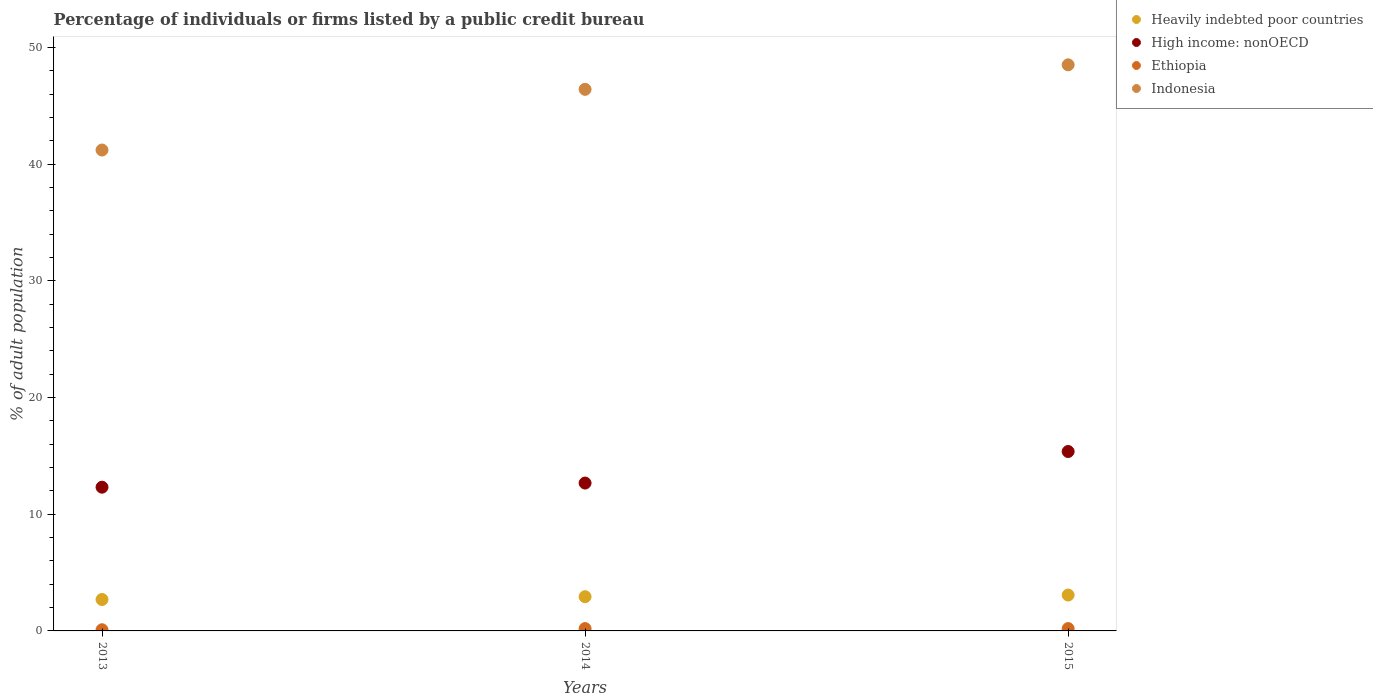What is the percentage of population listed by a public credit bureau in Heavily indebted poor countries in 2015?
Offer a terse response. 3.07. Across all years, what is the maximum percentage of population listed by a public credit bureau in Heavily indebted poor countries?
Give a very brief answer. 3.07. Across all years, what is the minimum percentage of population listed by a public credit bureau in Heavily indebted poor countries?
Offer a very short reply. 2.69. In which year was the percentage of population listed by a public credit bureau in Indonesia minimum?
Your answer should be very brief. 2013. What is the total percentage of population listed by a public credit bureau in Indonesia in the graph?
Keep it short and to the point. 136.1. What is the difference between the percentage of population listed by a public credit bureau in Ethiopia in 2014 and that in 2015?
Make the answer very short. 0. What is the difference between the percentage of population listed by a public credit bureau in High income: nonOECD in 2015 and the percentage of population listed by a public credit bureau in Heavily indebted poor countries in 2013?
Your answer should be very brief. 12.68. What is the average percentage of population listed by a public credit bureau in Heavily indebted poor countries per year?
Your answer should be very brief. 2.9. In the year 2013, what is the difference between the percentage of population listed by a public credit bureau in Heavily indebted poor countries and percentage of population listed by a public credit bureau in Ethiopia?
Provide a succinct answer. 2.59. In how many years, is the percentage of population listed by a public credit bureau in Indonesia greater than 20 %?
Provide a short and direct response. 3. What is the ratio of the percentage of population listed by a public credit bureau in High income: nonOECD in 2013 to that in 2015?
Your response must be concise. 0.8. Is the percentage of population listed by a public credit bureau in Heavily indebted poor countries in 2013 less than that in 2015?
Give a very brief answer. Yes. Is the difference between the percentage of population listed by a public credit bureau in Heavily indebted poor countries in 2013 and 2015 greater than the difference between the percentage of population listed by a public credit bureau in Ethiopia in 2013 and 2015?
Make the answer very short. No. What is the difference between the highest and the second highest percentage of population listed by a public credit bureau in Heavily indebted poor countries?
Your response must be concise. 0.14. What is the difference between the highest and the lowest percentage of population listed by a public credit bureau in Indonesia?
Offer a very short reply. 7.3. In how many years, is the percentage of population listed by a public credit bureau in High income: nonOECD greater than the average percentage of population listed by a public credit bureau in High income: nonOECD taken over all years?
Provide a short and direct response. 1. Is it the case that in every year, the sum of the percentage of population listed by a public credit bureau in High income: nonOECD and percentage of population listed by a public credit bureau in Heavily indebted poor countries  is greater than the percentage of population listed by a public credit bureau in Ethiopia?
Your response must be concise. Yes. Does the percentage of population listed by a public credit bureau in High income: nonOECD monotonically increase over the years?
Make the answer very short. Yes. Is the percentage of population listed by a public credit bureau in High income: nonOECD strictly less than the percentage of population listed by a public credit bureau in Ethiopia over the years?
Provide a short and direct response. No. How many years are there in the graph?
Your answer should be compact. 3. What is the difference between two consecutive major ticks on the Y-axis?
Offer a terse response. 10. Does the graph contain grids?
Give a very brief answer. No. How many legend labels are there?
Your response must be concise. 4. How are the legend labels stacked?
Give a very brief answer. Vertical. What is the title of the graph?
Give a very brief answer. Percentage of individuals or firms listed by a public credit bureau. What is the label or title of the Y-axis?
Make the answer very short. % of adult population. What is the % of adult population in Heavily indebted poor countries in 2013?
Your answer should be compact. 2.69. What is the % of adult population of High income: nonOECD in 2013?
Make the answer very short. 12.31. What is the % of adult population of Indonesia in 2013?
Your response must be concise. 41.2. What is the % of adult population in Heavily indebted poor countries in 2014?
Your response must be concise. 2.93. What is the % of adult population in High income: nonOECD in 2014?
Provide a short and direct response. 12.67. What is the % of adult population of Ethiopia in 2014?
Your answer should be compact. 0.2. What is the % of adult population of Indonesia in 2014?
Ensure brevity in your answer.  46.4. What is the % of adult population in Heavily indebted poor countries in 2015?
Your answer should be very brief. 3.07. What is the % of adult population of High income: nonOECD in 2015?
Offer a very short reply. 15.37. What is the % of adult population in Ethiopia in 2015?
Give a very brief answer. 0.2. What is the % of adult population of Indonesia in 2015?
Make the answer very short. 48.5. Across all years, what is the maximum % of adult population in Heavily indebted poor countries?
Your answer should be compact. 3.07. Across all years, what is the maximum % of adult population in High income: nonOECD?
Ensure brevity in your answer.  15.37. Across all years, what is the maximum % of adult population in Ethiopia?
Ensure brevity in your answer.  0.2. Across all years, what is the maximum % of adult population in Indonesia?
Give a very brief answer. 48.5. Across all years, what is the minimum % of adult population in Heavily indebted poor countries?
Provide a succinct answer. 2.69. Across all years, what is the minimum % of adult population in High income: nonOECD?
Ensure brevity in your answer.  12.31. Across all years, what is the minimum % of adult population in Indonesia?
Make the answer very short. 41.2. What is the total % of adult population in Heavily indebted poor countries in the graph?
Provide a succinct answer. 8.7. What is the total % of adult population in High income: nonOECD in the graph?
Your answer should be compact. 40.35. What is the total % of adult population in Ethiopia in the graph?
Make the answer very short. 0.5. What is the total % of adult population in Indonesia in the graph?
Provide a short and direct response. 136.1. What is the difference between the % of adult population of Heavily indebted poor countries in 2013 and that in 2014?
Provide a succinct answer. -0.24. What is the difference between the % of adult population in High income: nonOECD in 2013 and that in 2014?
Make the answer very short. -0.35. What is the difference between the % of adult population in Heavily indebted poor countries in 2013 and that in 2015?
Give a very brief answer. -0.38. What is the difference between the % of adult population of High income: nonOECD in 2013 and that in 2015?
Your answer should be very brief. -3.06. What is the difference between the % of adult population of Heavily indebted poor countries in 2014 and that in 2015?
Your answer should be very brief. -0.14. What is the difference between the % of adult population in High income: nonOECD in 2014 and that in 2015?
Provide a short and direct response. -2.7. What is the difference between the % of adult population in Ethiopia in 2014 and that in 2015?
Offer a very short reply. 0. What is the difference between the % of adult population in Heavily indebted poor countries in 2013 and the % of adult population in High income: nonOECD in 2014?
Make the answer very short. -9.98. What is the difference between the % of adult population of Heavily indebted poor countries in 2013 and the % of adult population of Ethiopia in 2014?
Keep it short and to the point. 2.49. What is the difference between the % of adult population of Heavily indebted poor countries in 2013 and the % of adult population of Indonesia in 2014?
Keep it short and to the point. -43.71. What is the difference between the % of adult population of High income: nonOECD in 2013 and the % of adult population of Ethiopia in 2014?
Offer a terse response. 12.11. What is the difference between the % of adult population of High income: nonOECD in 2013 and the % of adult population of Indonesia in 2014?
Provide a succinct answer. -34.09. What is the difference between the % of adult population of Ethiopia in 2013 and the % of adult population of Indonesia in 2014?
Give a very brief answer. -46.3. What is the difference between the % of adult population in Heavily indebted poor countries in 2013 and the % of adult population in High income: nonOECD in 2015?
Provide a short and direct response. -12.68. What is the difference between the % of adult population of Heavily indebted poor countries in 2013 and the % of adult population of Ethiopia in 2015?
Your answer should be very brief. 2.49. What is the difference between the % of adult population in Heavily indebted poor countries in 2013 and the % of adult population in Indonesia in 2015?
Make the answer very short. -45.81. What is the difference between the % of adult population of High income: nonOECD in 2013 and the % of adult population of Ethiopia in 2015?
Offer a terse response. 12.11. What is the difference between the % of adult population of High income: nonOECD in 2013 and the % of adult population of Indonesia in 2015?
Offer a very short reply. -36.19. What is the difference between the % of adult population in Ethiopia in 2013 and the % of adult population in Indonesia in 2015?
Provide a succinct answer. -48.4. What is the difference between the % of adult population of Heavily indebted poor countries in 2014 and the % of adult population of High income: nonOECD in 2015?
Provide a short and direct response. -12.44. What is the difference between the % of adult population in Heavily indebted poor countries in 2014 and the % of adult population in Ethiopia in 2015?
Keep it short and to the point. 2.73. What is the difference between the % of adult population in Heavily indebted poor countries in 2014 and the % of adult population in Indonesia in 2015?
Offer a very short reply. -45.57. What is the difference between the % of adult population of High income: nonOECD in 2014 and the % of adult population of Ethiopia in 2015?
Your answer should be compact. 12.47. What is the difference between the % of adult population in High income: nonOECD in 2014 and the % of adult population in Indonesia in 2015?
Keep it short and to the point. -35.83. What is the difference between the % of adult population of Ethiopia in 2014 and the % of adult population of Indonesia in 2015?
Offer a terse response. -48.3. What is the average % of adult population of Heavily indebted poor countries per year?
Your answer should be compact. 2.9. What is the average % of adult population in High income: nonOECD per year?
Keep it short and to the point. 13.45. What is the average % of adult population in Ethiopia per year?
Offer a very short reply. 0.17. What is the average % of adult population of Indonesia per year?
Your answer should be compact. 45.37. In the year 2013, what is the difference between the % of adult population of Heavily indebted poor countries and % of adult population of High income: nonOECD?
Keep it short and to the point. -9.62. In the year 2013, what is the difference between the % of adult population in Heavily indebted poor countries and % of adult population in Ethiopia?
Ensure brevity in your answer.  2.59. In the year 2013, what is the difference between the % of adult population in Heavily indebted poor countries and % of adult population in Indonesia?
Offer a very short reply. -38.51. In the year 2013, what is the difference between the % of adult population of High income: nonOECD and % of adult population of Ethiopia?
Provide a succinct answer. 12.21. In the year 2013, what is the difference between the % of adult population in High income: nonOECD and % of adult population in Indonesia?
Ensure brevity in your answer.  -28.89. In the year 2013, what is the difference between the % of adult population in Ethiopia and % of adult population in Indonesia?
Your answer should be very brief. -41.1. In the year 2014, what is the difference between the % of adult population in Heavily indebted poor countries and % of adult population in High income: nonOECD?
Give a very brief answer. -9.74. In the year 2014, what is the difference between the % of adult population of Heavily indebted poor countries and % of adult population of Ethiopia?
Ensure brevity in your answer.  2.73. In the year 2014, what is the difference between the % of adult population of Heavily indebted poor countries and % of adult population of Indonesia?
Offer a very short reply. -43.47. In the year 2014, what is the difference between the % of adult population in High income: nonOECD and % of adult population in Ethiopia?
Make the answer very short. 12.47. In the year 2014, what is the difference between the % of adult population in High income: nonOECD and % of adult population in Indonesia?
Your response must be concise. -33.73. In the year 2014, what is the difference between the % of adult population in Ethiopia and % of adult population in Indonesia?
Give a very brief answer. -46.2. In the year 2015, what is the difference between the % of adult population of Heavily indebted poor countries and % of adult population of High income: nonOECD?
Give a very brief answer. -12.3. In the year 2015, what is the difference between the % of adult population of Heavily indebted poor countries and % of adult population of Ethiopia?
Offer a very short reply. 2.87. In the year 2015, what is the difference between the % of adult population of Heavily indebted poor countries and % of adult population of Indonesia?
Ensure brevity in your answer.  -45.43. In the year 2015, what is the difference between the % of adult population of High income: nonOECD and % of adult population of Ethiopia?
Offer a terse response. 15.17. In the year 2015, what is the difference between the % of adult population of High income: nonOECD and % of adult population of Indonesia?
Offer a very short reply. -33.13. In the year 2015, what is the difference between the % of adult population of Ethiopia and % of adult population of Indonesia?
Your response must be concise. -48.3. What is the ratio of the % of adult population in Heavily indebted poor countries in 2013 to that in 2014?
Ensure brevity in your answer.  0.92. What is the ratio of the % of adult population of High income: nonOECD in 2013 to that in 2014?
Provide a succinct answer. 0.97. What is the ratio of the % of adult population of Indonesia in 2013 to that in 2014?
Give a very brief answer. 0.89. What is the ratio of the % of adult population of Heavily indebted poor countries in 2013 to that in 2015?
Provide a succinct answer. 0.88. What is the ratio of the % of adult population in High income: nonOECD in 2013 to that in 2015?
Provide a succinct answer. 0.8. What is the ratio of the % of adult population of Ethiopia in 2013 to that in 2015?
Give a very brief answer. 0.5. What is the ratio of the % of adult population in Indonesia in 2013 to that in 2015?
Provide a short and direct response. 0.85. What is the ratio of the % of adult population in Heavily indebted poor countries in 2014 to that in 2015?
Provide a succinct answer. 0.95. What is the ratio of the % of adult population of High income: nonOECD in 2014 to that in 2015?
Ensure brevity in your answer.  0.82. What is the ratio of the % of adult population of Indonesia in 2014 to that in 2015?
Give a very brief answer. 0.96. What is the difference between the highest and the second highest % of adult population in Heavily indebted poor countries?
Ensure brevity in your answer.  0.14. What is the difference between the highest and the second highest % of adult population of High income: nonOECD?
Your answer should be very brief. 2.7. What is the difference between the highest and the second highest % of adult population of Indonesia?
Your answer should be very brief. 2.1. What is the difference between the highest and the lowest % of adult population of Heavily indebted poor countries?
Your response must be concise. 0.38. What is the difference between the highest and the lowest % of adult population in High income: nonOECD?
Offer a very short reply. 3.06. What is the difference between the highest and the lowest % of adult population in Indonesia?
Give a very brief answer. 7.3. 